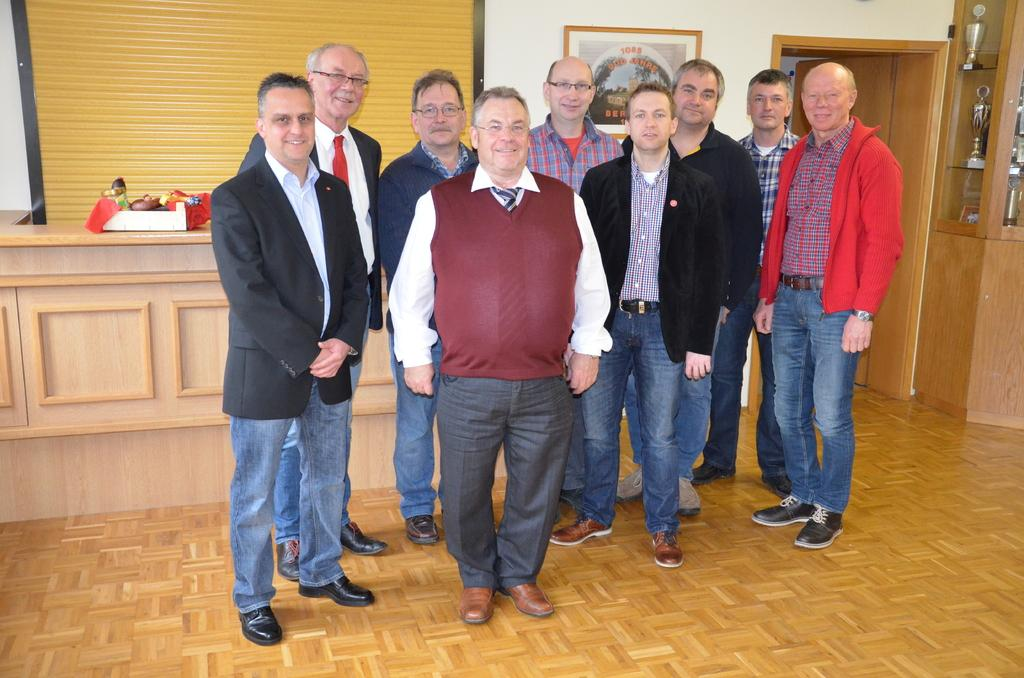How many people are in the image? There is a group of men in the image. What are the men doing in the image? The men are standing in front of the camera and posing for the camera. What can be seen in the background of the image? There is a wall, a photo frame hanging on the wall, a wooden table, and a door in the background. What type of glove is the man wearing in the image? There are no gloves visible in the image; the men are not wearing any gloves. What wish does the group of men have in the image? There is no indication of a wish in the image; the men are simply posing for a photo. 